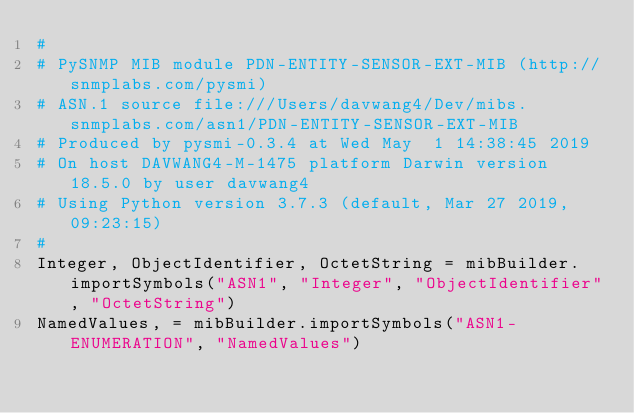Convert code to text. <code><loc_0><loc_0><loc_500><loc_500><_Python_>#
# PySNMP MIB module PDN-ENTITY-SENSOR-EXT-MIB (http://snmplabs.com/pysmi)
# ASN.1 source file:///Users/davwang4/Dev/mibs.snmplabs.com/asn1/PDN-ENTITY-SENSOR-EXT-MIB
# Produced by pysmi-0.3.4 at Wed May  1 14:38:45 2019
# On host DAVWANG4-M-1475 platform Darwin version 18.5.0 by user davwang4
# Using Python version 3.7.3 (default, Mar 27 2019, 09:23:15) 
#
Integer, ObjectIdentifier, OctetString = mibBuilder.importSymbols("ASN1", "Integer", "ObjectIdentifier", "OctetString")
NamedValues, = mibBuilder.importSymbols("ASN1-ENUMERATION", "NamedValues")</code> 